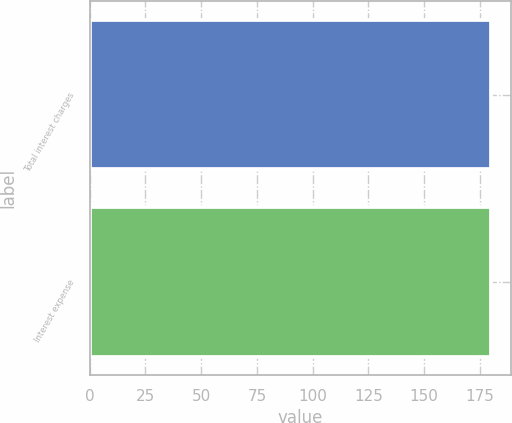Convert chart to OTSL. <chart><loc_0><loc_0><loc_500><loc_500><bar_chart><fcel>Total interest charges<fcel>Interest expense<nl><fcel>180<fcel>180.1<nl></chart> 